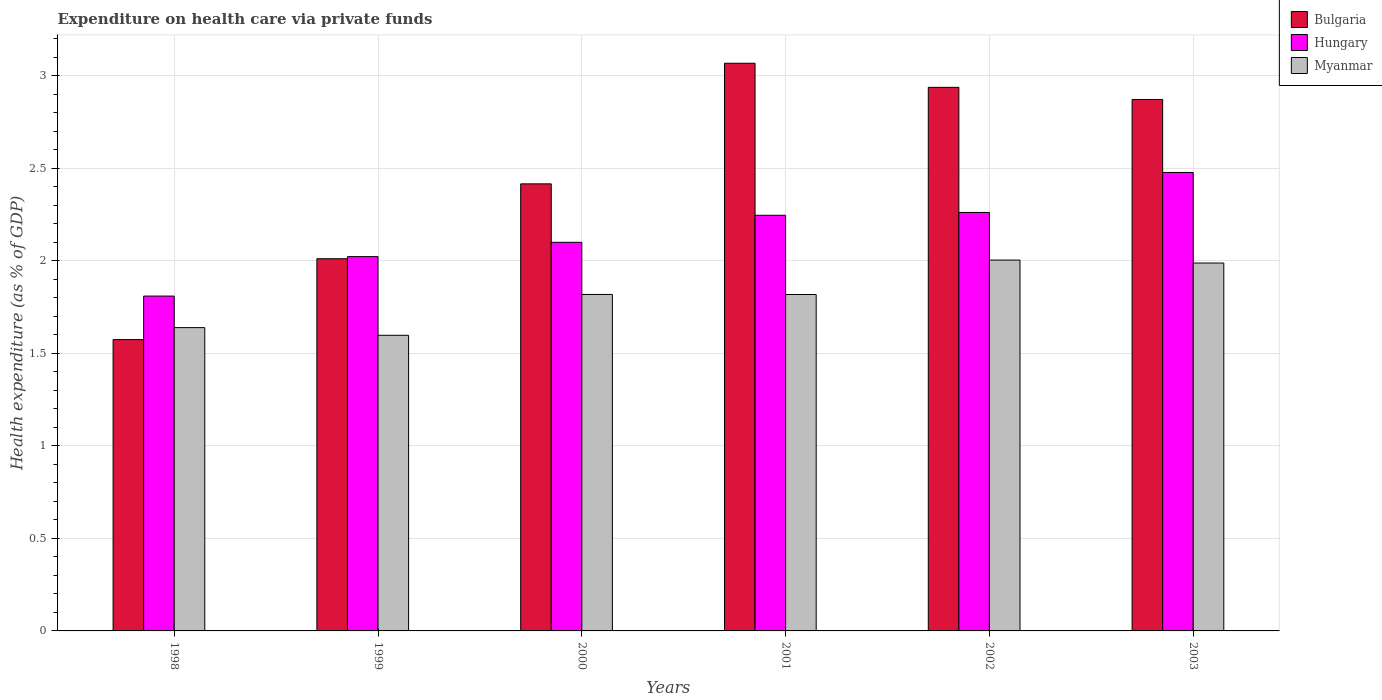How many different coloured bars are there?
Keep it short and to the point. 3. How many bars are there on the 3rd tick from the right?
Make the answer very short. 3. In how many cases, is the number of bars for a given year not equal to the number of legend labels?
Offer a very short reply. 0. What is the expenditure made on health care in Myanmar in 2002?
Your answer should be compact. 2. Across all years, what is the maximum expenditure made on health care in Myanmar?
Keep it short and to the point. 2. Across all years, what is the minimum expenditure made on health care in Hungary?
Offer a terse response. 1.81. In which year was the expenditure made on health care in Myanmar maximum?
Make the answer very short. 2002. What is the total expenditure made on health care in Myanmar in the graph?
Offer a terse response. 10.87. What is the difference between the expenditure made on health care in Bulgaria in 2000 and that in 2001?
Your response must be concise. -0.65. What is the difference between the expenditure made on health care in Myanmar in 2003 and the expenditure made on health care in Bulgaria in 1999?
Offer a very short reply. -0.02. What is the average expenditure made on health care in Hungary per year?
Your answer should be very brief. 2.15. In the year 2000, what is the difference between the expenditure made on health care in Myanmar and expenditure made on health care in Bulgaria?
Make the answer very short. -0.6. What is the ratio of the expenditure made on health care in Myanmar in 2000 to that in 2003?
Your answer should be compact. 0.91. What is the difference between the highest and the second highest expenditure made on health care in Myanmar?
Give a very brief answer. 0.02. What is the difference between the highest and the lowest expenditure made on health care in Myanmar?
Offer a terse response. 0.41. What does the 1st bar from the right in 2000 represents?
Offer a very short reply. Myanmar. How many bars are there?
Your answer should be very brief. 18. Does the graph contain any zero values?
Give a very brief answer. No. Where does the legend appear in the graph?
Provide a succinct answer. Top right. How many legend labels are there?
Provide a succinct answer. 3. How are the legend labels stacked?
Your response must be concise. Vertical. What is the title of the graph?
Offer a terse response. Expenditure on health care via private funds. Does "Northern Mariana Islands" appear as one of the legend labels in the graph?
Offer a terse response. No. What is the label or title of the X-axis?
Provide a succinct answer. Years. What is the label or title of the Y-axis?
Your answer should be compact. Health expenditure (as % of GDP). What is the Health expenditure (as % of GDP) in Bulgaria in 1998?
Provide a short and direct response. 1.57. What is the Health expenditure (as % of GDP) in Hungary in 1998?
Ensure brevity in your answer.  1.81. What is the Health expenditure (as % of GDP) of Myanmar in 1998?
Your answer should be compact. 1.64. What is the Health expenditure (as % of GDP) in Bulgaria in 1999?
Give a very brief answer. 2.01. What is the Health expenditure (as % of GDP) of Hungary in 1999?
Keep it short and to the point. 2.02. What is the Health expenditure (as % of GDP) of Myanmar in 1999?
Give a very brief answer. 1.6. What is the Health expenditure (as % of GDP) in Bulgaria in 2000?
Provide a succinct answer. 2.42. What is the Health expenditure (as % of GDP) in Hungary in 2000?
Ensure brevity in your answer.  2.1. What is the Health expenditure (as % of GDP) in Myanmar in 2000?
Your response must be concise. 1.82. What is the Health expenditure (as % of GDP) of Bulgaria in 2001?
Keep it short and to the point. 3.07. What is the Health expenditure (as % of GDP) of Hungary in 2001?
Offer a terse response. 2.25. What is the Health expenditure (as % of GDP) of Myanmar in 2001?
Your answer should be very brief. 1.82. What is the Health expenditure (as % of GDP) in Bulgaria in 2002?
Offer a very short reply. 2.94. What is the Health expenditure (as % of GDP) of Hungary in 2002?
Give a very brief answer. 2.26. What is the Health expenditure (as % of GDP) of Myanmar in 2002?
Your response must be concise. 2. What is the Health expenditure (as % of GDP) in Bulgaria in 2003?
Offer a very short reply. 2.87. What is the Health expenditure (as % of GDP) of Hungary in 2003?
Ensure brevity in your answer.  2.48. What is the Health expenditure (as % of GDP) in Myanmar in 2003?
Provide a short and direct response. 1.99. Across all years, what is the maximum Health expenditure (as % of GDP) of Bulgaria?
Offer a very short reply. 3.07. Across all years, what is the maximum Health expenditure (as % of GDP) in Hungary?
Provide a short and direct response. 2.48. Across all years, what is the maximum Health expenditure (as % of GDP) in Myanmar?
Provide a succinct answer. 2. Across all years, what is the minimum Health expenditure (as % of GDP) in Bulgaria?
Offer a terse response. 1.57. Across all years, what is the minimum Health expenditure (as % of GDP) of Hungary?
Provide a short and direct response. 1.81. Across all years, what is the minimum Health expenditure (as % of GDP) of Myanmar?
Make the answer very short. 1.6. What is the total Health expenditure (as % of GDP) of Bulgaria in the graph?
Give a very brief answer. 14.88. What is the total Health expenditure (as % of GDP) of Hungary in the graph?
Offer a very short reply. 12.92. What is the total Health expenditure (as % of GDP) in Myanmar in the graph?
Your response must be concise. 10.87. What is the difference between the Health expenditure (as % of GDP) in Bulgaria in 1998 and that in 1999?
Provide a short and direct response. -0.44. What is the difference between the Health expenditure (as % of GDP) of Hungary in 1998 and that in 1999?
Your answer should be compact. -0.21. What is the difference between the Health expenditure (as % of GDP) in Myanmar in 1998 and that in 1999?
Provide a short and direct response. 0.04. What is the difference between the Health expenditure (as % of GDP) in Bulgaria in 1998 and that in 2000?
Give a very brief answer. -0.84. What is the difference between the Health expenditure (as % of GDP) of Hungary in 1998 and that in 2000?
Provide a succinct answer. -0.29. What is the difference between the Health expenditure (as % of GDP) in Myanmar in 1998 and that in 2000?
Offer a terse response. -0.18. What is the difference between the Health expenditure (as % of GDP) of Bulgaria in 1998 and that in 2001?
Your response must be concise. -1.49. What is the difference between the Health expenditure (as % of GDP) of Hungary in 1998 and that in 2001?
Offer a terse response. -0.44. What is the difference between the Health expenditure (as % of GDP) of Myanmar in 1998 and that in 2001?
Give a very brief answer. -0.18. What is the difference between the Health expenditure (as % of GDP) in Bulgaria in 1998 and that in 2002?
Your answer should be very brief. -1.36. What is the difference between the Health expenditure (as % of GDP) in Hungary in 1998 and that in 2002?
Your answer should be compact. -0.45. What is the difference between the Health expenditure (as % of GDP) in Myanmar in 1998 and that in 2002?
Your answer should be very brief. -0.37. What is the difference between the Health expenditure (as % of GDP) in Bulgaria in 1998 and that in 2003?
Offer a very short reply. -1.3. What is the difference between the Health expenditure (as % of GDP) of Hungary in 1998 and that in 2003?
Ensure brevity in your answer.  -0.67. What is the difference between the Health expenditure (as % of GDP) in Myanmar in 1998 and that in 2003?
Your answer should be very brief. -0.35. What is the difference between the Health expenditure (as % of GDP) of Bulgaria in 1999 and that in 2000?
Keep it short and to the point. -0.4. What is the difference between the Health expenditure (as % of GDP) in Hungary in 1999 and that in 2000?
Offer a very short reply. -0.08. What is the difference between the Health expenditure (as % of GDP) in Myanmar in 1999 and that in 2000?
Provide a short and direct response. -0.22. What is the difference between the Health expenditure (as % of GDP) in Bulgaria in 1999 and that in 2001?
Ensure brevity in your answer.  -1.06. What is the difference between the Health expenditure (as % of GDP) in Hungary in 1999 and that in 2001?
Keep it short and to the point. -0.22. What is the difference between the Health expenditure (as % of GDP) of Myanmar in 1999 and that in 2001?
Offer a very short reply. -0.22. What is the difference between the Health expenditure (as % of GDP) of Bulgaria in 1999 and that in 2002?
Provide a succinct answer. -0.93. What is the difference between the Health expenditure (as % of GDP) in Hungary in 1999 and that in 2002?
Make the answer very short. -0.24. What is the difference between the Health expenditure (as % of GDP) of Myanmar in 1999 and that in 2002?
Make the answer very short. -0.41. What is the difference between the Health expenditure (as % of GDP) in Bulgaria in 1999 and that in 2003?
Ensure brevity in your answer.  -0.86. What is the difference between the Health expenditure (as % of GDP) in Hungary in 1999 and that in 2003?
Your answer should be very brief. -0.45. What is the difference between the Health expenditure (as % of GDP) of Myanmar in 1999 and that in 2003?
Ensure brevity in your answer.  -0.39. What is the difference between the Health expenditure (as % of GDP) of Bulgaria in 2000 and that in 2001?
Provide a short and direct response. -0.65. What is the difference between the Health expenditure (as % of GDP) of Hungary in 2000 and that in 2001?
Your response must be concise. -0.15. What is the difference between the Health expenditure (as % of GDP) of Bulgaria in 2000 and that in 2002?
Your answer should be very brief. -0.52. What is the difference between the Health expenditure (as % of GDP) in Hungary in 2000 and that in 2002?
Keep it short and to the point. -0.16. What is the difference between the Health expenditure (as % of GDP) in Myanmar in 2000 and that in 2002?
Offer a very short reply. -0.19. What is the difference between the Health expenditure (as % of GDP) of Bulgaria in 2000 and that in 2003?
Your answer should be compact. -0.46. What is the difference between the Health expenditure (as % of GDP) of Hungary in 2000 and that in 2003?
Your answer should be compact. -0.38. What is the difference between the Health expenditure (as % of GDP) in Myanmar in 2000 and that in 2003?
Give a very brief answer. -0.17. What is the difference between the Health expenditure (as % of GDP) of Bulgaria in 2001 and that in 2002?
Your response must be concise. 0.13. What is the difference between the Health expenditure (as % of GDP) of Hungary in 2001 and that in 2002?
Give a very brief answer. -0.02. What is the difference between the Health expenditure (as % of GDP) in Myanmar in 2001 and that in 2002?
Offer a terse response. -0.19. What is the difference between the Health expenditure (as % of GDP) of Bulgaria in 2001 and that in 2003?
Offer a very short reply. 0.2. What is the difference between the Health expenditure (as % of GDP) of Hungary in 2001 and that in 2003?
Make the answer very short. -0.23. What is the difference between the Health expenditure (as % of GDP) of Myanmar in 2001 and that in 2003?
Offer a terse response. -0.17. What is the difference between the Health expenditure (as % of GDP) of Bulgaria in 2002 and that in 2003?
Give a very brief answer. 0.07. What is the difference between the Health expenditure (as % of GDP) in Hungary in 2002 and that in 2003?
Keep it short and to the point. -0.22. What is the difference between the Health expenditure (as % of GDP) of Myanmar in 2002 and that in 2003?
Your answer should be very brief. 0.02. What is the difference between the Health expenditure (as % of GDP) in Bulgaria in 1998 and the Health expenditure (as % of GDP) in Hungary in 1999?
Offer a terse response. -0.45. What is the difference between the Health expenditure (as % of GDP) in Bulgaria in 1998 and the Health expenditure (as % of GDP) in Myanmar in 1999?
Provide a succinct answer. -0.02. What is the difference between the Health expenditure (as % of GDP) in Hungary in 1998 and the Health expenditure (as % of GDP) in Myanmar in 1999?
Ensure brevity in your answer.  0.21. What is the difference between the Health expenditure (as % of GDP) in Bulgaria in 1998 and the Health expenditure (as % of GDP) in Hungary in 2000?
Give a very brief answer. -0.53. What is the difference between the Health expenditure (as % of GDP) in Bulgaria in 1998 and the Health expenditure (as % of GDP) in Myanmar in 2000?
Provide a short and direct response. -0.24. What is the difference between the Health expenditure (as % of GDP) of Hungary in 1998 and the Health expenditure (as % of GDP) of Myanmar in 2000?
Your answer should be compact. -0.01. What is the difference between the Health expenditure (as % of GDP) of Bulgaria in 1998 and the Health expenditure (as % of GDP) of Hungary in 2001?
Keep it short and to the point. -0.67. What is the difference between the Health expenditure (as % of GDP) in Bulgaria in 1998 and the Health expenditure (as % of GDP) in Myanmar in 2001?
Provide a succinct answer. -0.24. What is the difference between the Health expenditure (as % of GDP) in Hungary in 1998 and the Health expenditure (as % of GDP) in Myanmar in 2001?
Ensure brevity in your answer.  -0.01. What is the difference between the Health expenditure (as % of GDP) in Bulgaria in 1998 and the Health expenditure (as % of GDP) in Hungary in 2002?
Your answer should be compact. -0.69. What is the difference between the Health expenditure (as % of GDP) of Bulgaria in 1998 and the Health expenditure (as % of GDP) of Myanmar in 2002?
Your response must be concise. -0.43. What is the difference between the Health expenditure (as % of GDP) in Hungary in 1998 and the Health expenditure (as % of GDP) in Myanmar in 2002?
Ensure brevity in your answer.  -0.19. What is the difference between the Health expenditure (as % of GDP) of Bulgaria in 1998 and the Health expenditure (as % of GDP) of Hungary in 2003?
Ensure brevity in your answer.  -0.9. What is the difference between the Health expenditure (as % of GDP) in Bulgaria in 1998 and the Health expenditure (as % of GDP) in Myanmar in 2003?
Provide a succinct answer. -0.41. What is the difference between the Health expenditure (as % of GDP) in Hungary in 1998 and the Health expenditure (as % of GDP) in Myanmar in 2003?
Your answer should be compact. -0.18. What is the difference between the Health expenditure (as % of GDP) in Bulgaria in 1999 and the Health expenditure (as % of GDP) in Hungary in 2000?
Make the answer very short. -0.09. What is the difference between the Health expenditure (as % of GDP) of Bulgaria in 1999 and the Health expenditure (as % of GDP) of Myanmar in 2000?
Keep it short and to the point. 0.19. What is the difference between the Health expenditure (as % of GDP) of Hungary in 1999 and the Health expenditure (as % of GDP) of Myanmar in 2000?
Keep it short and to the point. 0.2. What is the difference between the Health expenditure (as % of GDP) of Bulgaria in 1999 and the Health expenditure (as % of GDP) of Hungary in 2001?
Provide a short and direct response. -0.23. What is the difference between the Health expenditure (as % of GDP) in Bulgaria in 1999 and the Health expenditure (as % of GDP) in Myanmar in 2001?
Give a very brief answer. 0.19. What is the difference between the Health expenditure (as % of GDP) of Hungary in 1999 and the Health expenditure (as % of GDP) of Myanmar in 2001?
Offer a terse response. 0.2. What is the difference between the Health expenditure (as % of GDP) of Bulgaria in 1999 and the Health expenditure (as % of GDP) of Hungary in 2002?
Offer a very short reply. -0.25. What is the difference between the Health expenditure (as % of GDP) in Bulgaria in 1999 and the Health expenditure (as % of GDP) in Myanmar in 2002?
Provide a short and direct response. 0.01. What is the difference between the Health expenditure (as % of GDP) in Hungary in 1999 and the Health expenditure (as % of GDP) in Myanmar in 2002?
Your answer should be very brief. 0.02. What is the difference between the Health expenditure (as % of GDP) of Bulgaria in 1999 and the Health expenditure (as % of GDP) of Hungary in 2003?
Offer a very short reply. -0.47. What is the difference between the Health expenditure (as % of GDP) of Bulgaria in 1999 and the Health expenditure (as % of GDP) of Myanmar in 2003?
Offer a terse response. 0.02. What is the difference between the Health expenditure (as % of GDP) of Hungary in 1999 and the Health expenditure (as % of GDP) of Myanmar in 2003?
Make the answer very short. 0.03. What is the difference between the Health expenditure (as % of GDP) in Bulgaria in 2000 and the Health expenditure (as % of GDP) in Hungary in 2001?
Your answer should be very brief. 0.17. What is the difference between the Health expenditure (as % of GDP) in Bulgaria in 2000 and the Health expenditure (as % of GDP) in Myanmar in 2001?
Provide a short and direct response. 0.6. What is the difference between the Health expenditure (as % of GDP) of Hungary in 2000 and the Health expenditure (as % of GDP) of Myanmar in 2001?
Provide a succinct answer. 0.28. What is the difference between the Health expenditure (as % of GDP) in Bulgaria in 2000 and the Health expenditure (as % of GDP) in Hungary in 2002?
Keep it short and to the point. 0.15. What is the difference between the Health expenditure (as % of GDP) of Bulgaria in 2000 and the Health expenditure (as % of GDP) of Myanmar in 2002?
Give a very brief answer. 0.41. What is the difference between the Health expenditure (as % of GDP) in Hungary in 2000 and the Health expenditure (as % of GDP) in Myanmar in 2002?
Ensure brevity in your answer.  0.1. What is the difference between the Health expenditure (as % of GDP) of Bulgaria in 2000 and the Health expenditure (as % of GDP) of Hungary in 2003?
Provide a succinct answer. -0.06. What is the difference between the Health expenditure (as % of GDP) in Bulgaria in 2000 and the Health expenditure (as % of GDP) in Myanmar in 2003?
Provide a succinct answer. 0.43. What is the difference between the Health expenditure (as % of GDP) in Hungary in 2000 and the Health expenditure (as % of GDP) in Myanmar in 2003?
Your response must be concise. 0.11. What is the difference between the Health expenditure (as % of GDP) in Bulgaria in 2001 and the Health expenditure (as % of GDP) in Hungary in 2002?
Your answer should be compact. 0.81. What is the difference between the Health expenditure (as % of GDP) in Bulgaria in 2001 and the Health expenditure (as % of GDP) in Myanmar in 2002?
Provide a short and direct response. 1.06. What is the difference between the Health expenditure (as % of GDP) of Hungary in 2001 and the Health expenditure (as % of GDP) of Myanmar in 2002?
Your answer should be compact. 0.24. What is the difference between the Health expenditure (as % of GDP) of Bulgaria in 2001 and the Health expenditure (as % of GDP) of Hungary in 2003?
Make the answer very short. 0.59. What is the difference between the Health expenditure (as % of GDP) in Bulgaria in 2001 and the Health expenditure (as % of GDP) in Myanmar in 2003?
Ensure brevity in your answer.  1.08. What is the difference between the Health expenditure (as % of GDP) in Hungary in 2001 and the Health expenditure (as % of GDP) in Myanmar in 2003?
Make the answer very short. 0.26. What is the difference between the Health expenditure (as % of GDP) in Bulgaria in 2002 and the Health expenditure (as % of GDP) in Hungary in 2003?
Your response must be concise. 0.46. What is the difference between the Health expenditure (as % of GDP) of Bulgaria in 2002 and the Health expenditure (as % of GDP) of Myanmar in 2003?
Offer a very short reply. 0.95. What is the difference between the Health expenditure (as % of GDP) of Hungary in 2002 and the Health expenditure (as % of GDP) of Myanmar in 2003?
Offer a very short reply. 0.27. What is the average Health expenditure (as % of GDP) of Bulgaria per year?
Your answer should be very brief. 2.48. What is the average Health expenditure (as % of GDP) of Hungary per year?
Provide a succinct answer. 2.15. What is the average Health expenditure (as % of GDP) of Myanmar per year?
Give a very brief answer. 1.81. In the year 1998, what is the difference between the Health expenditure (as % of GDP) in Bulgaria and Health expenditure (as % of GDP) in Hungary?
Your answer should be very brief. -0.24. In the year 1998, what is the difference between the Health expenditure (as % of GDP) of Bulgaria and Health expenditure (as % of GDP) of Myanmar?
Ensure brevity in your answer.  -0.06. In the year 1998, what is the difference between the Health expenditure (as % of GDP) in Hungary and Health expenditure (as % of GDP) in Myanmar?
Provide a succinct answer. 0.17. In the year 1999, what is the difference between the Health expenditure (as % of GDP) in Bulgaria and Health expenditure (as % of GDP) in Hungary?
Give a very brief answer. -0.01. In the year 1999, what is the difference between the Health expenditure (as % of GDP) of Bulgaria and Health expenditure (as % of GDP) of Myanmar?
Your answer should be compact. 0.41. In the year 1999, what is the difference between the Health expenditure (as % of GDP) in Hungary and Health expenditure (as % of GDP) in Myanmar?
Give a very brief answer. 0.43. In the year 2000, what is the difference between the Health expenditure (as % of GDP) in Bulgaria and Health expenditure (as % of GDP) in Hungary?
Give a very brief answer. 0.32. In the year 2000, what is the difference between the Health expenditure (as % of GDP) in Bulgaria and Health expenditure (as % of GDP) in Myanmar?
Your response must be concise. 0.6. In the year 2000, what is the difference between the Health expenditure (as % of GDP) in Hungary and Health expenditure (as % of GDP) in Myanmar?
Offer a very short reply. 0.28. In the year 2001, what is the difference between the Health expenditure (as % of GDP) of Bulgaria and Health expenditure (as % of GDP) of Hungary?
Keep it short and to the point. 0.82. In the year 2001, what is the difference between the Health expenditure (as % of GDP) of Bulgaria and Health expenditure (as % of GDP) of Myanmar?
Ensure brevity in your answer.  1.25. In the year 2001, what is the difference between the Health expenditure (as % of GDP) in Hungary and Health expenditure (as % of GDP) in Myanmar?
Your answer should be compact. 0.43. In the year 2002, what is the difference between the Health expenditure (as % of GDP) of Bulgaria and Health expenditure (as % of GDP) of Hungary?
Your answer should be very brief. 0.68. In the year 2002, what is the difference between the Health expenditure (as % of GDP) of Bulgaria and Health expenditure (as % of GDP) of Myanmar?
Offer a terse response. 0.93. In the year 2002, what is the difference between the Health expenditure (as % of GDP) of Hungary and Health expenditure (as % of GDP) of Myanmar?
Your response must be concise. 0.26. In the year 2003, what is the difference between the Health expenditure (as % of GDP) of Bulgaria and Health expenditure (as % of GDP) of Hungary?
Make the answer very short. 0.39. In the year 2003, what is the difference between the Health expenditure (as % of GDP) of Bulgaria and Health expenditure (as % of GDP) of Myanmar?
Give a very brief answer. 0.88. In the year 2003, what is the difference between the Health expenditure (as % of GDP) of Hungary and Health expenditure (as % of GDP) of Myanmar?
Keep it short and to the point. 0.49. What is the ratio of the Health expenditure (as % of GDP) of Bulgaria in 1998 to that in 1999?
Provide a succinct answer. 0.78. What is the ratio of the Health expenditure (as % of GDP) in Hungary in 1998 to that in 1999?
Your answer should be compact. 0.89. What is the ratio of the Health expenditure (as % of GDP) in Bulgaria in 1998 to that in 2000?
Your answer should be compact. 0.65. What is the ratio of the Health expenditure (as % of GDP) in Hungary in 1998 to that in 2000?
Keep it short and to the point. 0.86. What is the ratio of the Health expenditure (as % of GDP) of Myanmar in 1998 to that in 2000?
Offer a terse response. 0.9. What is the ratio of the Health expenditure (as % of GDP) of Bulgaria in 1998 to that in 2001?
Your response must be concise. 0.51. What is the ratio of the Health expenditure (as % of GDP) of Hungary in 1998 to that in 2001?
Offer a terse response. 0.81. What is the ratio of the Health expenditure (as % of GDP) in Myanmar in 1998 to that in 2001?
Provide a short and direct response. 0.9. What is the ratio of the Health expenditure (as % of GDP) of Bulgaria in 1998 to that in 2002?
Keep it short and to the point. 0.54. What is the ratio of the Health expenditure (as % of GDP) of Hungary in 1998 to that in 2002?
Provide a succinct answer. 0.8. What is the ratio of the Health expenditure (as % of GDP) in Myanmar in 1998 to that in 2002?
Offer a terse response. 0.82. What is the ratio of the Health expenditure (as % of GDP) of Bulgaria in 1998 to that in 2003?
Ensure brevity in your answer.  0.55. What is the ratio of the Health expenditure (as % of GDP) of Hungary in 1998 to that in 2003?
Offer a terse response. 0.73. What is the ratio of the Health expenditure (as % of GDP) in Myanmar in 1998 to that in 2003?
Give a very brief answer. 0.82. What is the ratio of the Health expenditure (as % of GDP) in Bulgaria in 1999 to that in 2000?
Your answer should be compact. 0.83. What is the ratio of the Health expenditure (as % of GDP) of Hungary in 1999 to that in 2000?
Provide a succinct answer. 0.96. What is the ratio of the Health expenditure (as % of GDP) of Myanmar in 1999 to that in 2000?
Give a very brief answer. 0.88. What is the ratio of the Health expenditure (as % of GDP) of Bulgaria in 1999 to that in 2001?
Keep it short and to the point. 0.66. What is the ratio of the Health expenditure (as % of GDP) in Hungary in 1999 to that in 2001?
Offer a very short reply. 0.9. What is the ratio of the Health expenditure (as % of GDP) in Myanmar in 1999 to that in 2001?
Make the answer very short. 0.88. What is the ratio of the Health expenditure (as % of GDP) in Bulgaria in 1999 to that in 2002?
Ensure brevity in your answer.  0.68. What is the ratio of the Health expenditure (as % of GDP) in Hungary in 1999 to that in 2002?
Offer a terse response. 0.89. What is the ratio of the Health expenditure (as % of GDP) in Myanmar in 1999 to that in 2002?
Give a very brief answer. 0.8. What is the ratio of the Health expenditure (as % of GDP) in Bulgaria in 1999 to that in 2003?
Make the answer very short. 0.7. What is the ratio of the Health expenditure (as % of GDP) in Hungary in 1999 to that in 2003?
Offer a very short reply. 0.82. What is the ratio of the Health expenditure (as % of GDP) of Myanmar in 1999 to that in 2003?
Give a very brief answer. 0.8. What is the ratio of the Health expenditure (as % of GDP) of Bulgaria in 2000 to that in 2001?
Provide a short and direct response. 0.79. What is the ratio of the Health expenditure (as % of GDP) of Hungary in 2000 to that in 2001?
Your response must be concise. 0.93. What is the ratio of the Health expenditure (as % of GDP) of Bulgaria in 2000 to that in 2002?
Make the answer very short. 0.82. What is the ratio of the Health expenditure (as % of GDP) of Hungary in 2000 to that in 2002?
Offer a very short reply. 0.93. What is the ratio of the Health expenditure (as % of GDP) of Myanmar in 2000 to that in 2002?
Your response must be concise. 0.91. What is the ratio of the Health expenditure (as % of GDP) of Bulgaria in 2000 to that in 2003?
Your answer should be compact. 0.84. What is the ratio of the Health expenditure (as % of GDP) of Hungary in 2000 to that in 2003?
Provide a short and direct response. 0.85. What is the ratio of the Health expenditure (as % of GDP) in Myanmar in 2000 to that in 2003?
Your answer should be very brief. 0.91. What is the ratio of the Health expenditure (as % of GDP) of Bulgaria in 2001 to that in 2002?
Offer a terse response. 1.04. What is the ratio of the Health expenditure (as % of GDP) in Myanmar in 2001 to that in 2002?
Offer a very short reply. 0.91. What is the ratio of the Health expenditure (as % of GDP) in Bulgaria in 2001 to that in 2003?
Keep it short and to the point. 1.07. What is the ratio of the Health expenditure (as % of GDP) of Hungary in 2001 to that in 2003?
Provide a succinct answer. 0.91. What is the ratio of the Health expenditure (as % of GDP) of Myanmar in 2001 to that in 2003?
Your answer should be compact. 0.91. What is the ratio of the Health expenditure (as % of GDP) in Bulgaria in 2002 to that in 2003?
Make the answer very short. 1.02. What is the ratio of the Health expenditure (as % of GDP) of Hungary in 2002 to that in 2003?
Provide a short and direct response. 0.91. What is the difference between the highest and the second highest Health expenditure (as % of GDP) in Bulgaria?
Make the answer very short. 0.13. What is the difference between the highest and the second highest Health expenditure (as % of GDP) of Hungary?
Ensure brevity in your answer.  0.22. What is the difference between the highest and the second highest Health expenditure (as % of GDP) in Myanmar?
Your answer should be very brief. 0.02. What is the difference between the highest and the lowest Health expenditure (as % of GDP) of Bulgaria?
Provide a succinct answer. 1.49. What is the difference between the highest and the lowest Health expenditure (as % of GDP) in Hungary?
Give a very brief answer. 0.67. What is the difference between the highest and the lowest Health expenditure (as % of GDP) in Myanmar?
Your answer should be compact. 0.41. 